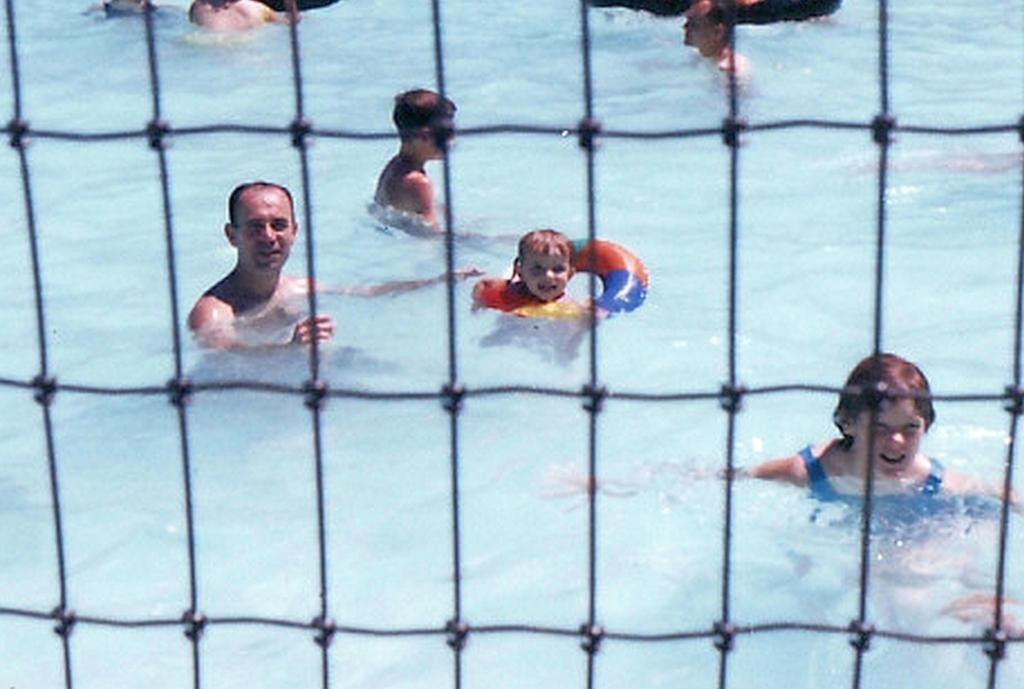What are the people in the image doing? The people in the image are in the water. What object is visible in the image? There is a net visible in the image. What type of cake is being served during the vacation in the image? There is no cake or vacation present in the image; it features people in the water and a net. What impulse might have led someone to bring the net into the water? The image does not provide any information about the reasons or motivations behind the presence of the net in the water. 